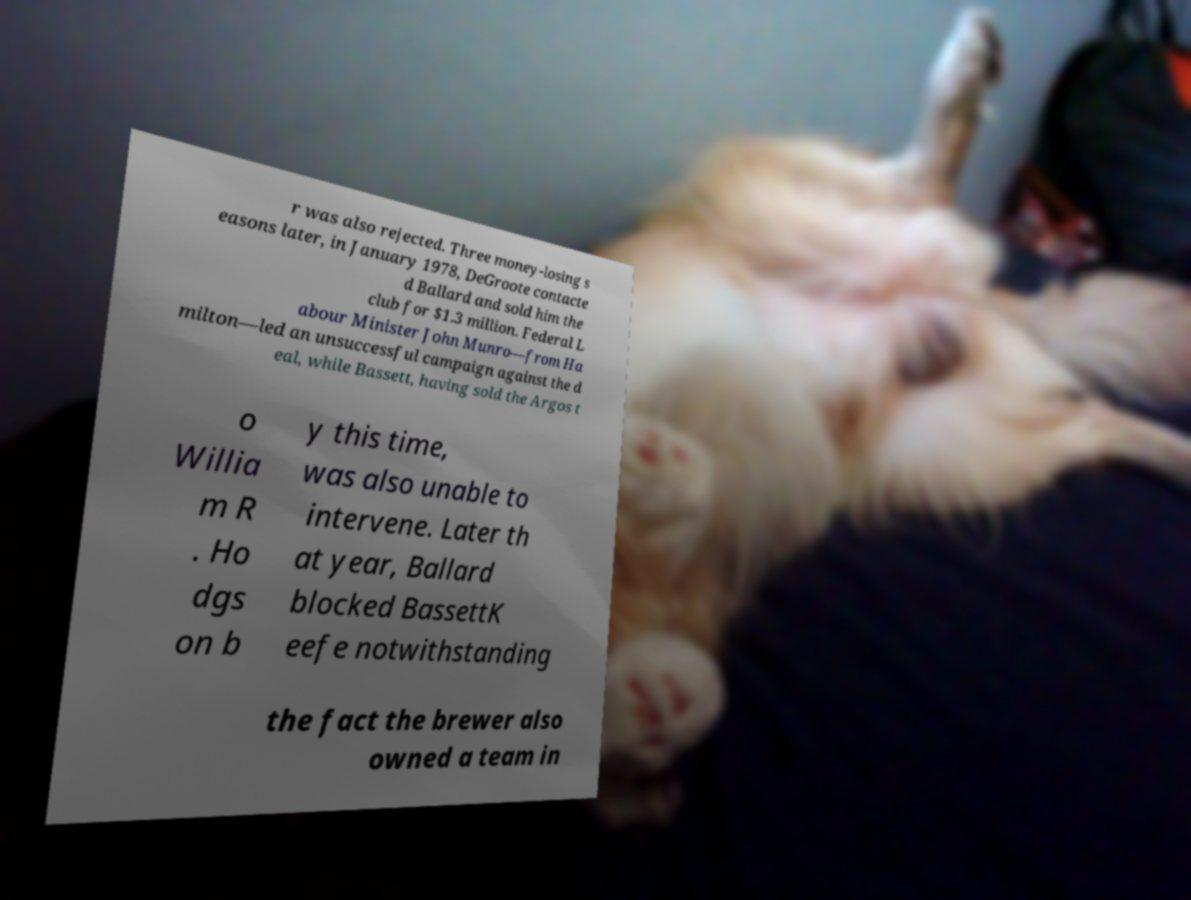Please read and relay the text visible in this image. What does it say? r was also rejected. Three money-losing s easons later, in January 1978, DeGroote contacte d Ballard and sold him the club for $1.3 million. Federal L abour Minister John Munro—from Ha milton—led an unsuccessful campaign against the d eal, while Bassett, having sold the Argos t o Willia m R . Ho dgs on b y this time, was also unable to intervene. Later th at year, Ballard blocked BassettK eefe notwithstanding the fact the brewer also owned a team in 